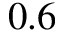Convert formula to latex. <formula><loc_0><loc_0><loc_500><loc_500>0 . 6</formula> 